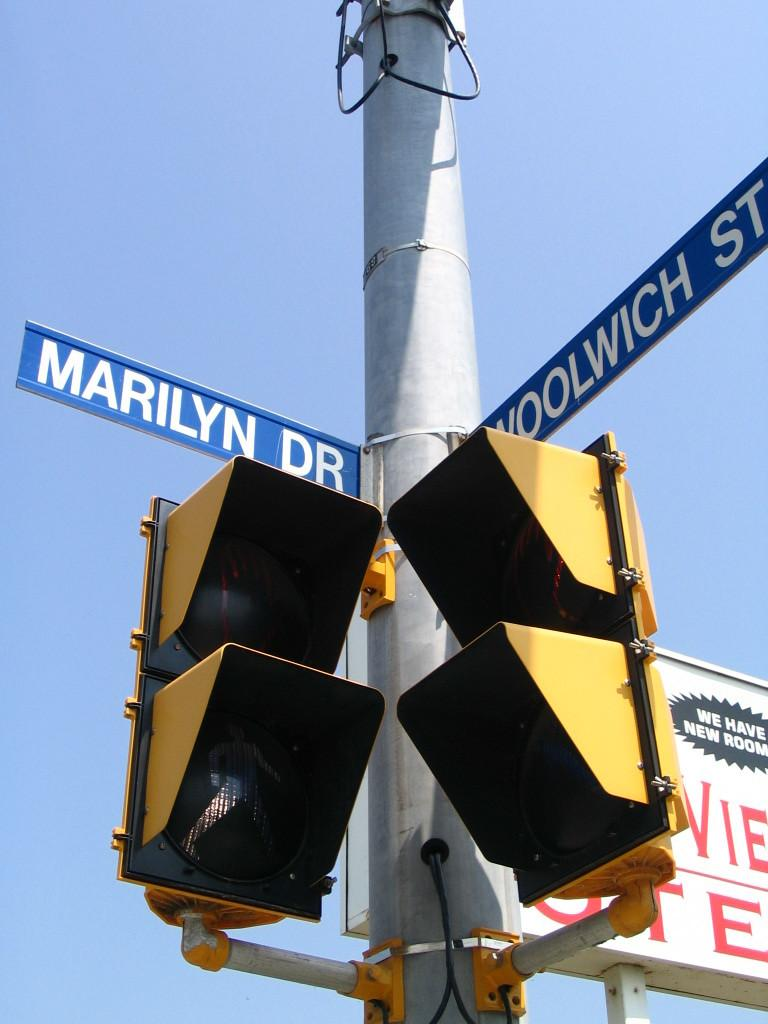<image>
Share a concise interpretation of the image provided. Crossing signals at the intersection of Marilyn Dr and Woolwich St. 